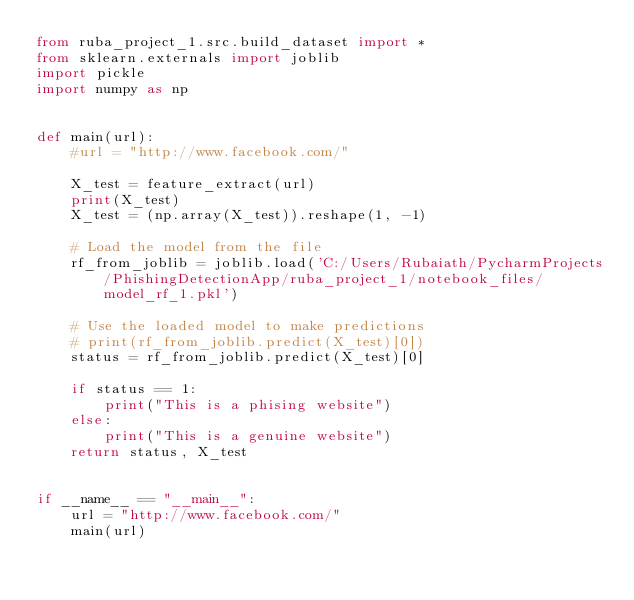<code> <loc_0><loc_0><loc_500><loc_500><_Python_>from ruba_project_1.src.build_dataset import *
from sklearn.externals import joblib
import pickle
import numpy as np


def main(url):
    #url = "http://www.facebook.com/"

    X_test = feature_extract(url)
    print(X_test)
    X_test = (np.array(X_test)).reshape(1, -1)

    # Load the model from the file
    rf_from_joblib = joblib.load('C:/Users/Rubaiath/PycharmProjects/PhishingDetectionApp/ruba_project_1/notebook_files/model_rf_1.pkl')

    # Use the loaded model to make predictions
    # print(rf_from_joblib.predict(X_test)[0])
    status = rf_from_joblib.predict(X_test)[0]

    if status == 1:
        print("This is a phising website")
    else:
        print("This is a genuine website")
    return status, X_test


if __name__ == "__main__":
    url = "http://www.facebook.com/"
    main(url)
</code> 